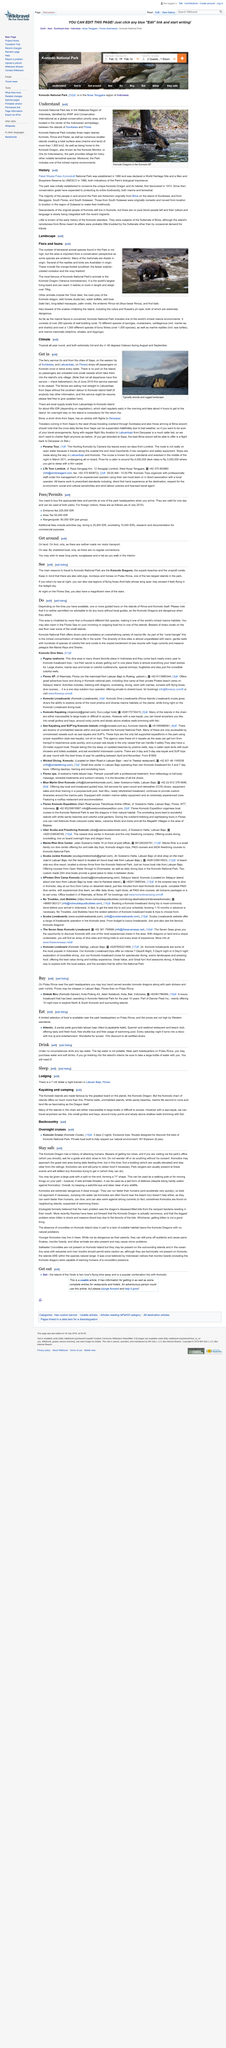Identify some key points in this picture. Komodo National Park is home to three major islands: Komodo, Rinca, and Padar. These islands are known for their rich biodiversity and unique ecosystems, featuring a wide variety of flora and fauna. The park is famous for its dragons, the largest lizards in the world, which can be found on the island of Komodo. In addition to the dragons, the park is also home to a wide range of other animals, including deer, wild pigs, and birds. The park is a popular destination for visitors interested in nature and conservation, and it is an important habitat for many endangered species. Komodo National Park, located in Indonesia, is a national park that covers a total marine and land surface area of more than 1,800 km2. It consists of three major islands, each with a unique character and ecosystem. The park's diverse flora and fauna, including the famous Komodo dragon, make it a popular destination for visitors. 